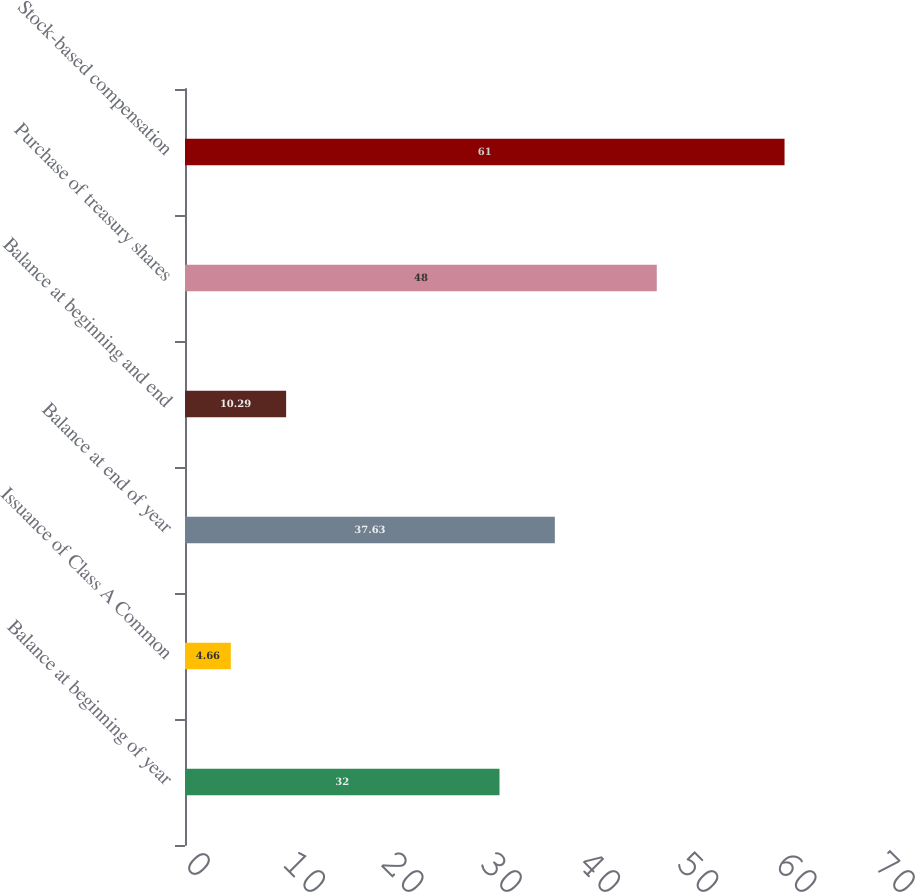Convert chart. <chart><loc_0><loc_0><loc_500><loc_500><bar_chart><fcel>Balance at beginning of year<fcel>Issuance of Class A Common<fcel>Balance at end of year<fcel>Balance at beginning and end<fcel>Purchase of treasury shares<fcel>Stock-based compensation<nl><fcel>32<fcel>4.66<fcel>37.63<fcel>10.29<fcel>48<fcel>61<nl></chart> 